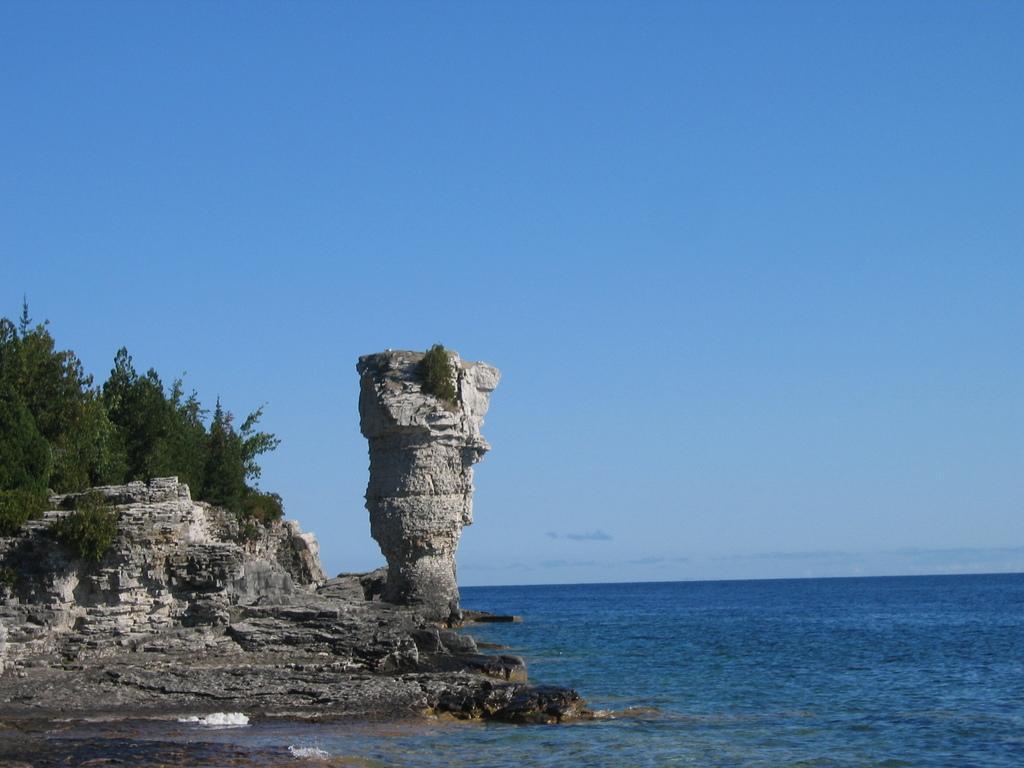Could you give a brief overview of what you see in this image? In this image at the bottom right there is the sea, at the bottom right there is collapsed monument and tree, at the top there is the sky. 